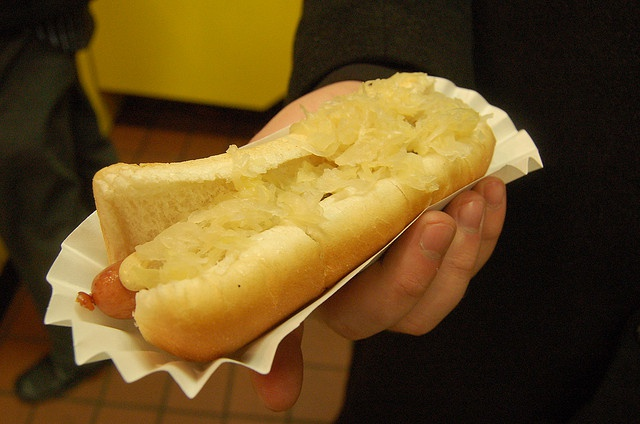Describe the objects in this image and their specific colors. I can see people in black, brown, and maroon tones, hot dog in black, tan, red, khaki, and orange tones, and people in black, maroon, and olive tones in this image. 